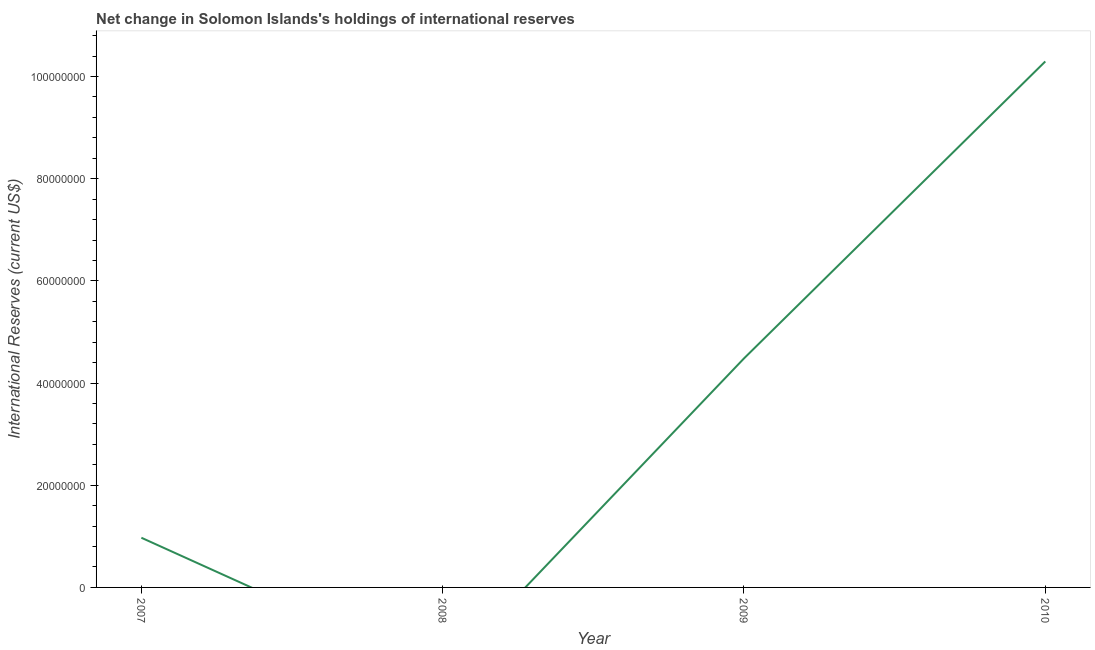What is the reserves and related items in 2007?
Offer a very short reply. 9.73e+06. Across all years, what is the maximum reserves and related items?
Offer a terse response. 1.03e+08. Across all years, what is the minimum reserves and related items?
Offer a very short reply. 0. What is the sum of the reserves and related items?
Offer a very short reply. 1.58e+08. What is the difference between the reserves and related items in 2007 and 2009?
Give a very brief answer. -3.51e+07. What is the average reserves and related items per year?
Your answer should be compact. 3.94e+07. What is the median reserves and related items?
Your answer should be very brief. 2.73e+07. In how many years, is the reserves and related items greater than 52000000 US$?
Your answer should be compact. 1. What is the ratio of the reserves and related items in 2007 to that in 2009?
Ensure brevity in your answer.  0.22. What is the difference between the highest and the second highest reserves and related items?
Your answer should be very brief. 5.81e+07. What is the difference between the highest and the lowest reserves and related items?
Provide a short and direct response. 1.03e+08. What is the difference between two consecutive major ticks on the Y-axis?
Give a very brief answer. 2.00e+07. Does the graph contain grids?
Offer a terse response. No. What is the title of the graph?
Give a very brief answer. Net change in Solomon Islands's holdings of international reserves. What is the label or title of the Y-axis?
Keep it short and to the point. International Reserves (current US$). What is the International Reserves (current US$) of 2007?
Offer a very short reply. 9.73e+06. What is the International Reserves (current US$) in 2008?
Your answer should be very brief. 0. What is the International Reserves (current US$) in 2009?
Offer a very short reply. 4.48e+07. What is the International Reserves (current US$) of 2010?
Your response must be concise. 1.03e+08. What is the difference between the International Reserves (current US$) in 2007 and 2009?
Your response must be concise. -3.51e+07. What is the difference between the International Reserves (current US$) in 2007 and 2010?
Keep it short and to the point. -9.32e+07. What is the difference between the International Reserves (current US$) in 2009 and 2010?
Make the answer very short. -5.81e+07. What is the ratio of the International Reserves (current US$) in 2007 to that in 2009?
Give a very brief answer. 0.22. What is the ratio of the International Reserves (current US$) in 2007 to that in 2010?
Your answer should be compact. 0.09. What is the ratio of the International Reserves (current US$) in 2009 to that in 2010?
Your answer should be compact. 0.43. 